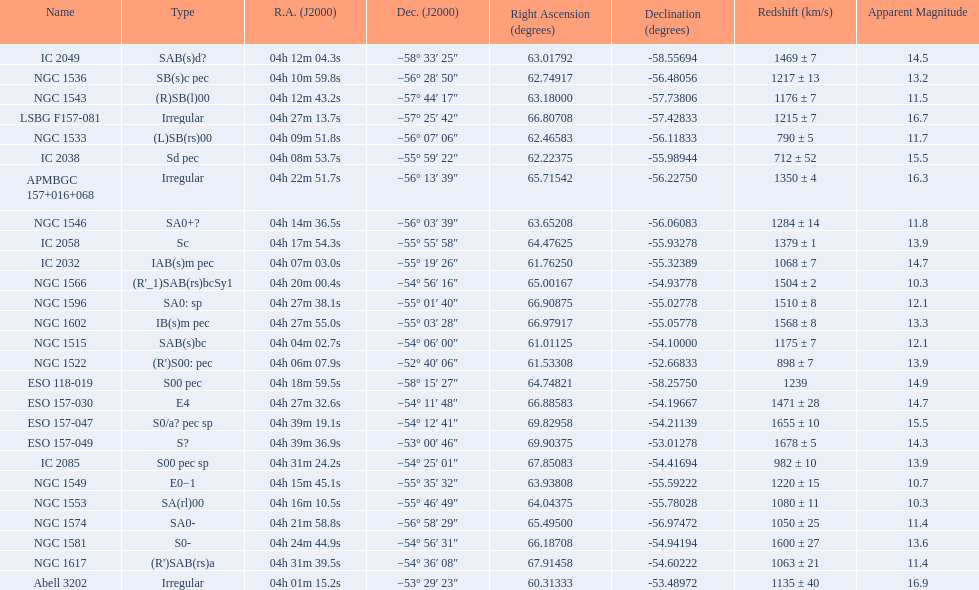What number of "irregular" types are there? 3. 